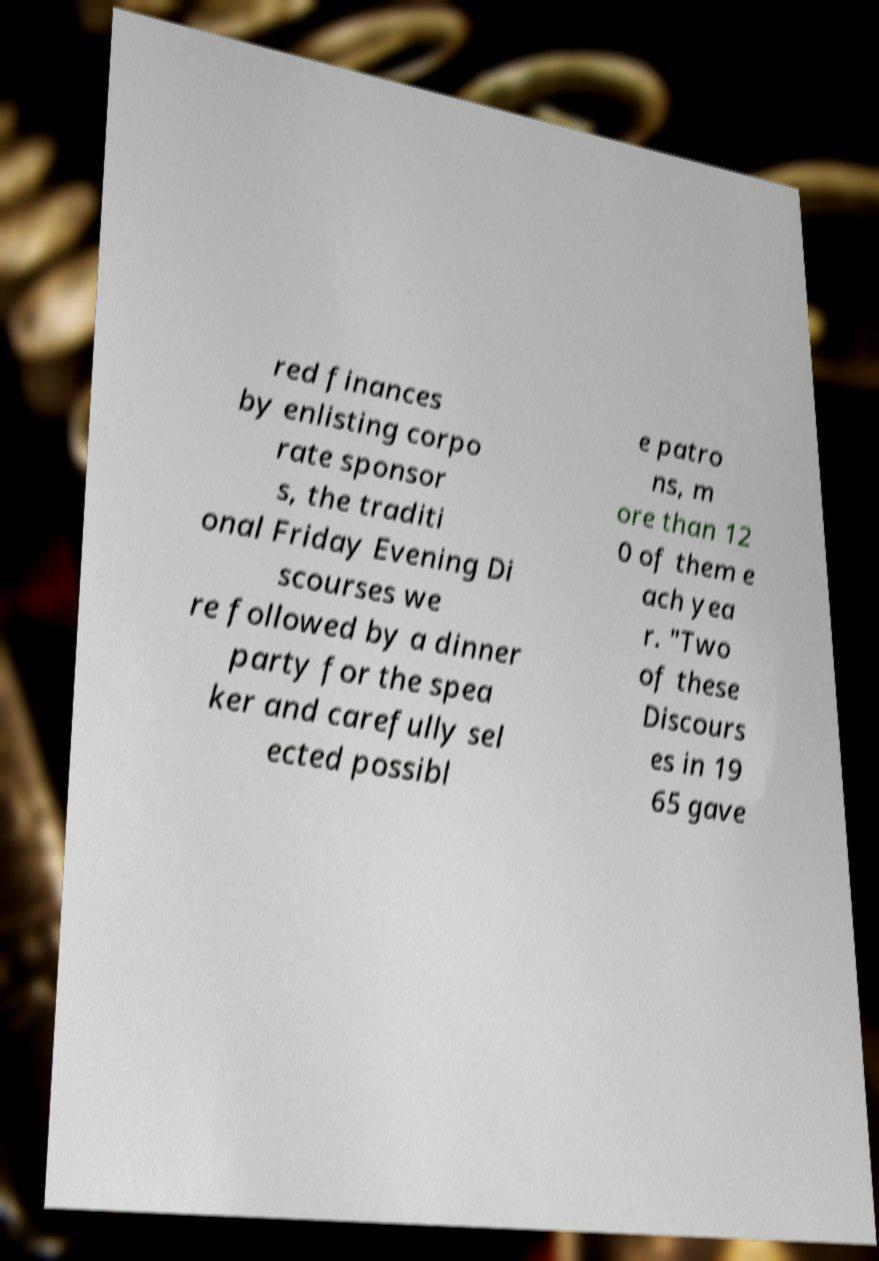Could you assist in decoding the text presented in this image and type it out clearly? red finances by enlisting corpo rate sponsor s, the traditi onal Friday Evening Di scourses we re followed by a dinner party for the spea ker and carefully sel ected possibl e patro ns, m ore than 12 0 of them e ach yea r. "Two of these Discours es in 19 65 gave 